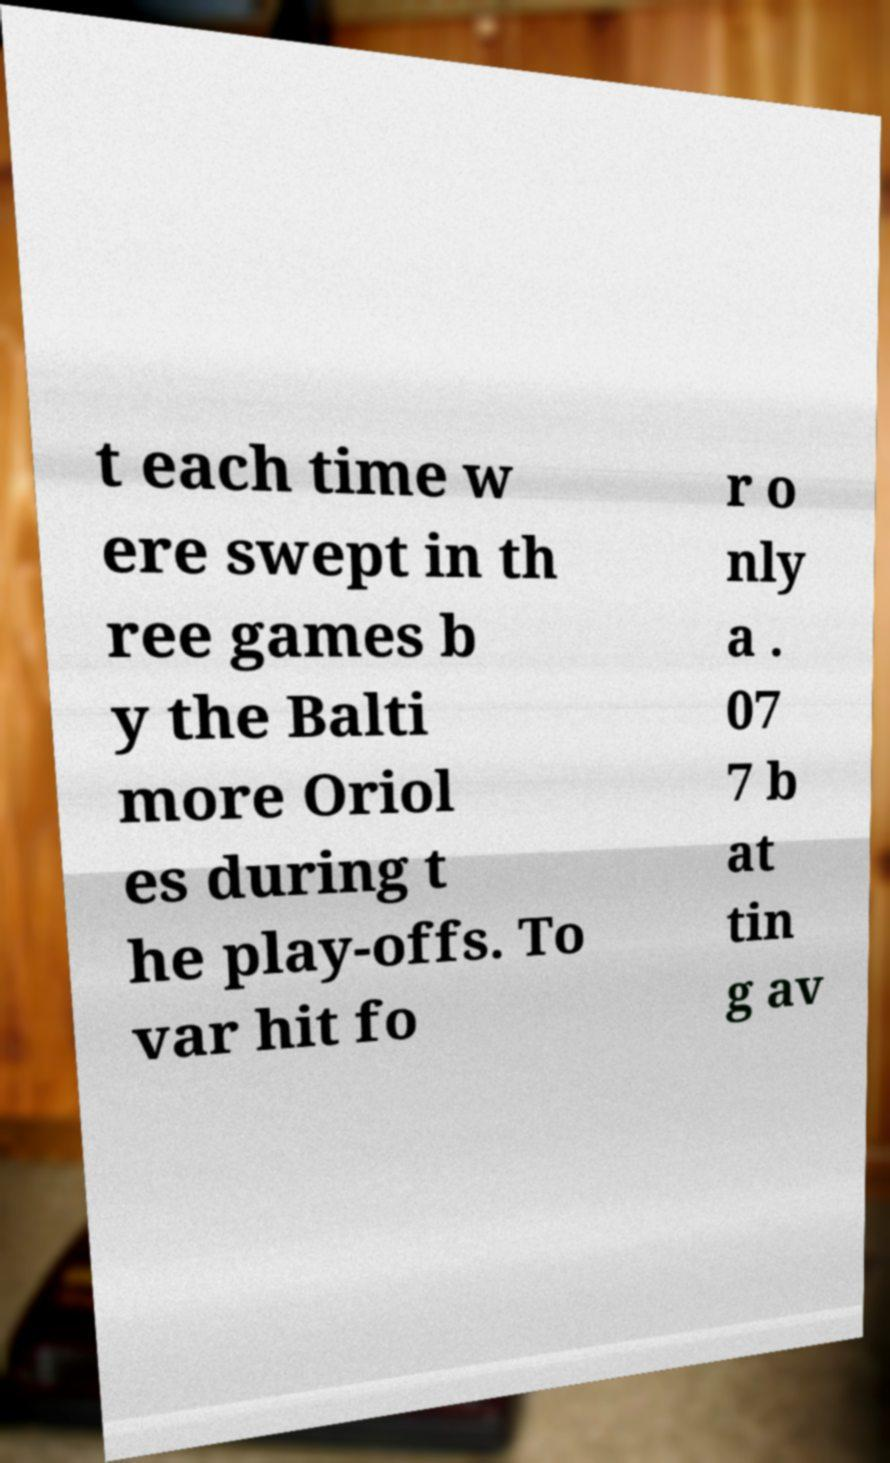Please read and relay the text visible in this image. What does it say? t each time w ere swept in th ree games b y the Balti more Oriol es during t he play-offs. To var hit fo r o nly a . 07 7 b at tin g av 